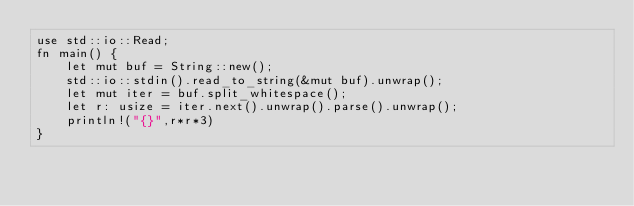Convert code to text. <code><loc_0><loc_0><loc_500><loc_500><_Rust_>use std::io::Read;
fn main() {
    let mut buf = String::new();
    std::io::stdin().read_to_string(&mut buf).unwrap();
    let mut iter = buf.split_whitespace();
    let r: usize = iter.next().unwrap().parse().unwrap();
    println!("{}",r*r*3)
}</code> 